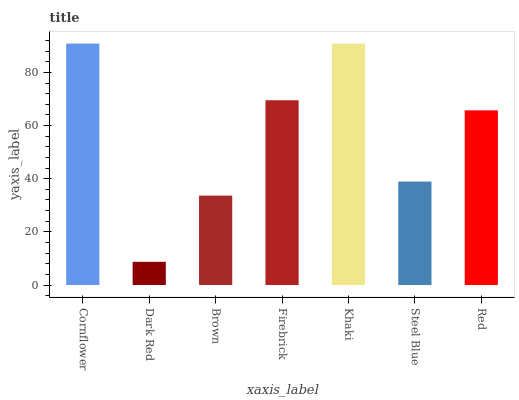Is Dark Red the minimum?
Answer yes or no. Yes. Is Cornflower the maximum?
Answer yes or no. Yes. Is Brown the minimum?
Answer yes or no. No. Is Brown the maximum?
Answer yes or no. No. Is Brown greater than Dark Red?
Answer yes or no. Yes. Is Dark Red less than Brown?
Answer yes or no. Yes. Is Dark Red greater than Brown?
Answer yes or no. No. Is Brown less than Dark Red?
Answer yes or no. No. Is Red the high median?
Answer yes or no. Yes. Is Red the low median?
Answer yes or no. Yes. Is Firebrick the high median?
Answer yes or no. No. Is Brown the low median?
Answer yes or no. No. 